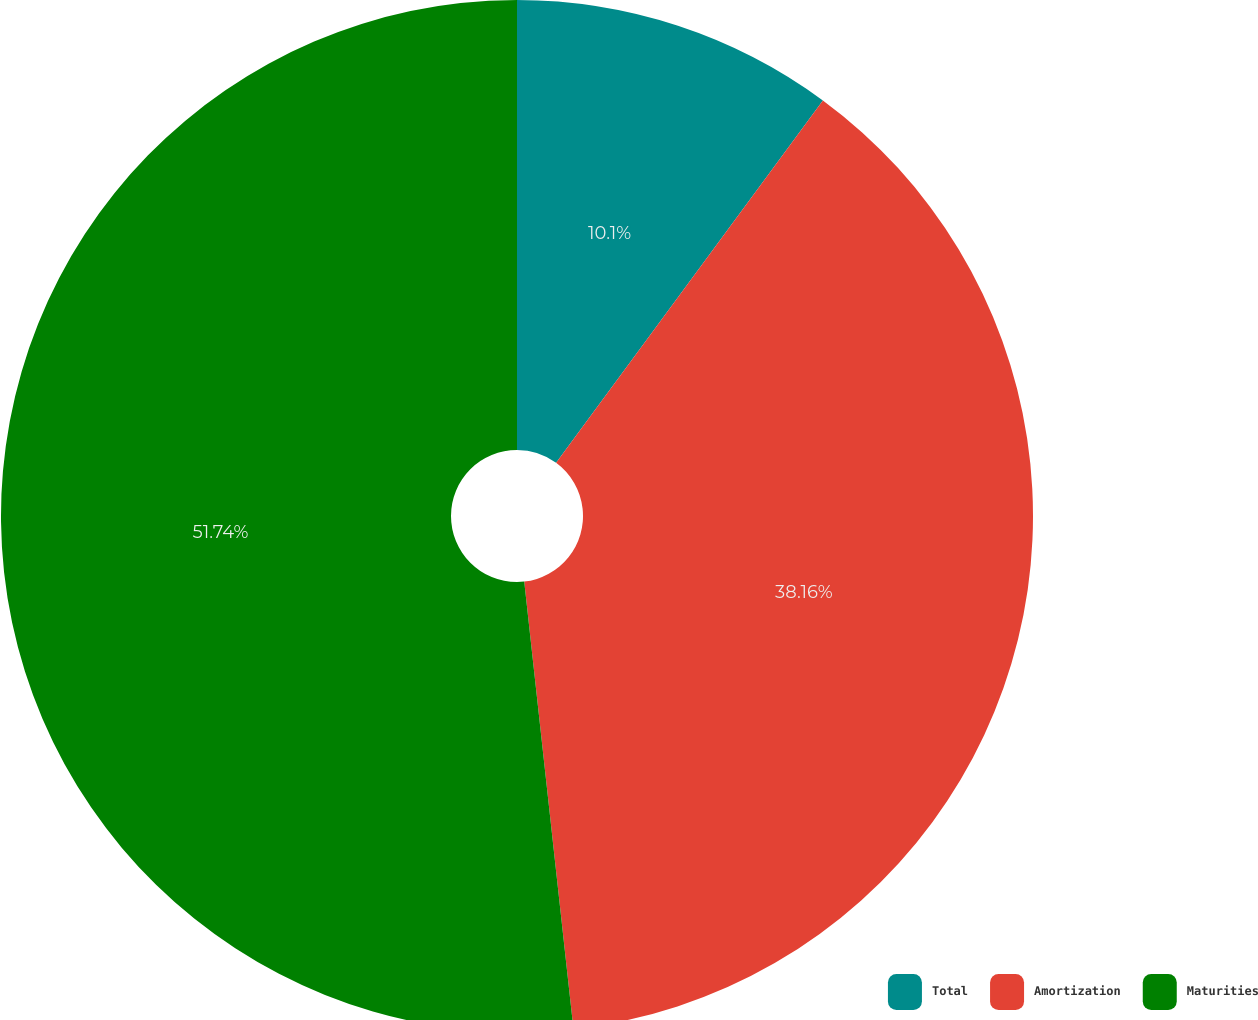Convert chart. <chart><loc_0><loc_0><loc_500><loc_500><pie_chart><fcel>Total<fcel>Amortization<fcel>Maturities<nl><fcel>10.1%<fcel>38.16%<fcel>51.75%<nl></chart> 